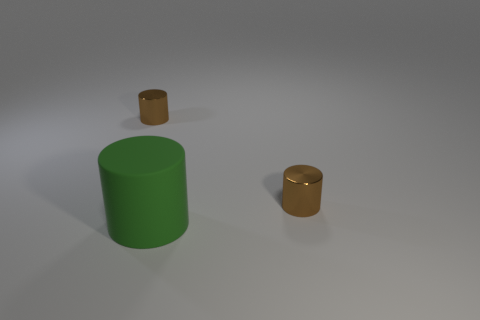There is a tiny brown cylinder left of the tiny metallic cylinder in front of the tiny shiny cylinder that is to the left of the green matte cylinder; what is its material?
Keep it short and to the point. Metal. Do the shiny thing that is on the right side of the green rubber cylinder and the brown shiny thing that is left of the big object have the same shape?
Provide a short and direct response. Yes. Are there any red spheres of the same size as the matte thing?
Your answer should be compact. No. How many purple things are either tiny shiny objects or large rubber cylinders?
Keep it short and to the point. 0. What number of spheres are either shiny objects or green rubber things?
Provide a succinct answer. 0. There is a small shiny object on the right side of the rubber object; what is its color?
Offer a very short reply. Brown. What number of big green matte cylinders are in front of the matte cylinder?
Offer a terse response. 0. What number of things are brown objects or big green rubber cylinders?
Your response must be concise. 3. How many large green rubber things are there?
Offer a very short reply. 1. Are there more brown objects than cylinders?
Ensure brevity in your answer.  No. 